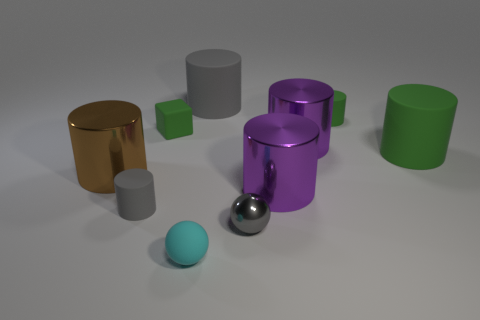There is a rubber object that is both behind the large green cylinder and left of the cyan ball; what shape is it?
Offer a terse response. Cube. There is a tiny matte cylinder to the left of the tiny gray shiny thing; are there any large objects in front of it?
Provide a short and direct response. No. How many other things are there of the same material as the tiny cyan ball?
Your answer should be very brief. 5. Is the shape of the big matte object behind the small green cube the same as the green matte thing that is left of the small cyan ball?
Ensure brevity in your answer.  No. Do the large brown cylinder and the green cube have the same material?
Your answer should be compact. No. How big is the metallic cylinder to the left of the gray cylinder on the right side of the small gray rubber cylinder behind the small cyan thing?
Give a very brief answer. Large. How many other things are there of the same color as the small matte ball?
Your response must be concise. 0. What shape is the cyan thing that is the same size as the gray sphere?
Your answer should be very brief. Sphere. How many tiny objects are red rubber cubes or brown objects?
Your answer should be very brief. 0. Are there any cylinders behind the small cylinder that is in front of the tiny green rubber thing that is behind the green matte cube?
Provide a succinct answer. Yes. 